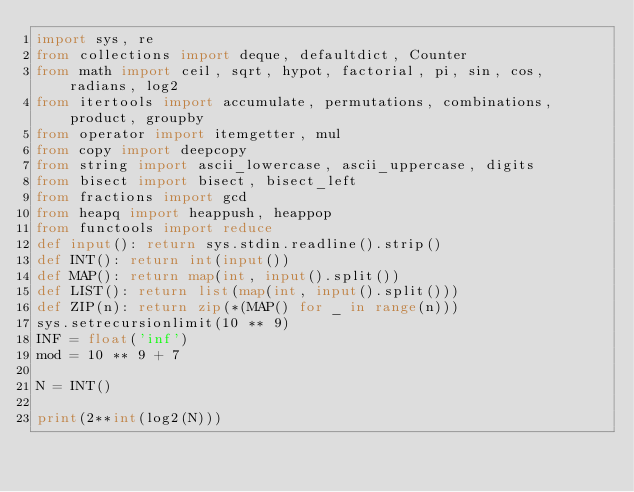<code> <loc_0><loc_0><loc_500><loc_500><_Python_>import sys, re
from collections import deque, defaultdict, Counter
from math import ceil, sqrt, hypot, factorial, pi, sin, cos, radians, log2
from itertools import accumulate, permutations, combinations, product, groupby
from operator import itemgetter, mul
from copy import deepcopy
from string import ascii_lowercase, ascii_uppercase, digits
from bisect import bisect, bisect_left
from fractions import gcd
from heapq import heappush, heappop
from functools import reduce
def input(): return sys.stdin.readline().strip()
def INT(): return int(input())
def MAP(): return map(int, input().split())
def LIST(): return list(map(int, input().split()))
def ZIP(n): return zip(*(MAP() for _ in range(n)))
sys.setrecursionlimit(10 ** 9)
INF = float('inf')
mod = 10 ** 9 + 7
 
N = INT()

print(2**int(log2(N)))</code> 